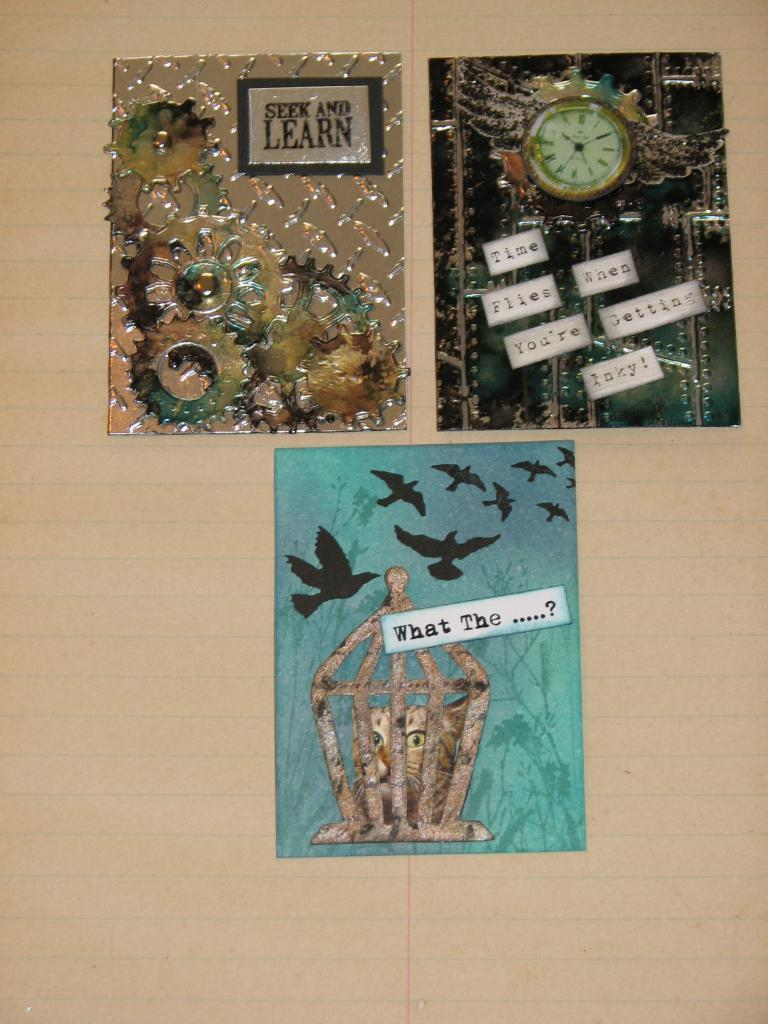<image>
Create a compact narrative representing the image presented. a sign that says seek and learn on it 